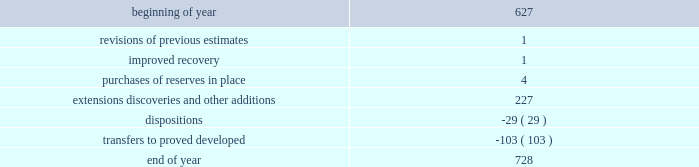During 2014 , 2013 and 2012 , netherland , sewell & associates , inc .
( "nsai" ) prepared a certification of the prior year's reserves for the alba field in e.g .
The nsai summary reports are filed as an exhibit to this annual report on form 10-k .
Members of the nsai team have multiple years of industry experience , having worked for large , international oil and gas companies before joining nsai .
The senior technical advisor has over 35 years of practical experience in petroleum geosciences , with over 15 years experience in the estimation and evaluation of reserves .
The second team member has over 10 years of practical experience in petroleum engineering , with 5 years experience in the estimation and evaluation of reserves .
Both are registered professional engineers in the state of texas .
Ryder scott company ( "ryder scott" ) also performed audits of the prior years' reserves of several of our fields in 2014 , 2013 and 2012 .
Their summary reports are filed as exhibits to this annual report on form 10-k .
The team lead for ryder scott has over 20 years of industry experience , having worked for a major international oil and gas company before joining ryder scott .
He is a member of spe , where he served on the oil and gas reserves committee , and is a registered professional engineer in the state of texas .
Changes in proved undeveloped reserves as of december 31 , 2014 , 728 mmboe of proved undeveloped reserves were reported , an increase of 101 mmboe from december 31 , 2013 .
The table shows changes in total proved undeveloped reserves for 2014 : ( mmboe ) .
Significant additions to proved undeveloped reserves during 2014 included 121 mmboe in the eagle ford and 61 mmboe in the bakken shale plays due to development drilling .
Transfers from proved undeveloped to proved developed reserves included 67 mmboe in the eagle ford , 26 mmboe in the bakken and 1 mmboe in the oklahoma resource basins due to development drilling and completions .
Costs incurred in 2014 , 2013 and 2012 relating to the development of proved undeveloped reserves , were $ 3149 million , $ 2536 million and $ 1995 million .
A total of 102 mmboe was booked as extensions , discoveries or other additions due to the application of reliable technology .
Technologies included statistical analysis of production performance , decline curve analysis , pressure and rate transient analysis , reservoir simulation and volumetric analysis .
The statistical nature of production performance coupled with highly certain reservoir continuity or quality within the reliable technology areas and sufficient proved undeveloped locations establish the reasonable certainty criteria required for booking proved reserves .
Projects can remain in proved undeveloped reserves for extended periods in certain situations such as large development projects which take more than five years to complete , or the timing of when additional gas compression is needed .
Of the 728 mmboe of proved undeveloped reserves at december 31 , 2014 , 19 percent of the volume is associated with projects that have been included in proved reserves for more than five years .
The majority of this volume is related to a compression project in e.g .
That was sanctioned by our board of directors in 2004 .
The timing of the installation of compression is being driven by the reservoir performance with this project intended to maintain maximum production levels .
Performance of this field since the board sanctioned the project has far exceeded expectations .
Estimates of initial dry gas in place increased by roughly 10 percent between 2004 and 2010 .
During 2012 , the compression project received the approval of the e.g .
Government , allowing design and planning work to progress towards implementation , with completion expected by mid-2016 .
The other component of alba proved undeveloped reserves is an infill well approved in 2013 and to be drilled in the second quarter of 2015 .
Proved undeveloped reserves for the north gialo development , located in the libyan sahara desert , were booked for the first time in 2010 .
This development , which is anticipated to take more than five years to develop , is executed by the operator and encompasses a multi-year drilling program including the design , fabrication and installation of extensive liquid handling and gas recycling facilities .
Anecdotal evidence from similar development projects in the region lead to an expected project execution time frame of more than five years from the time the reserves were initially booked .
Interruptions associated with the civil unrest in 2011 and third-party labor strikes and civil unrest in 2013-2014 have also extended the project duration .
As of december 31 , 2014 , future development costs estimated to be required for the development of proved undeveloped crude oil and condensate , ngls , natural gas and synthetic crude oil reserves related to continuing operations for the years 2015 through 2019 are projected to be $ 2915 million , $ 2598 million , $ 2493 million , $ 2669 million and $ 2745 million. .
What were total costs incurred in 2014 , 2013 and 2012 relating to the development of proved undeveloped reserves , in millions? 
Computations: ((3149 + 2536) + 1995)
Answer: 7680.0. 